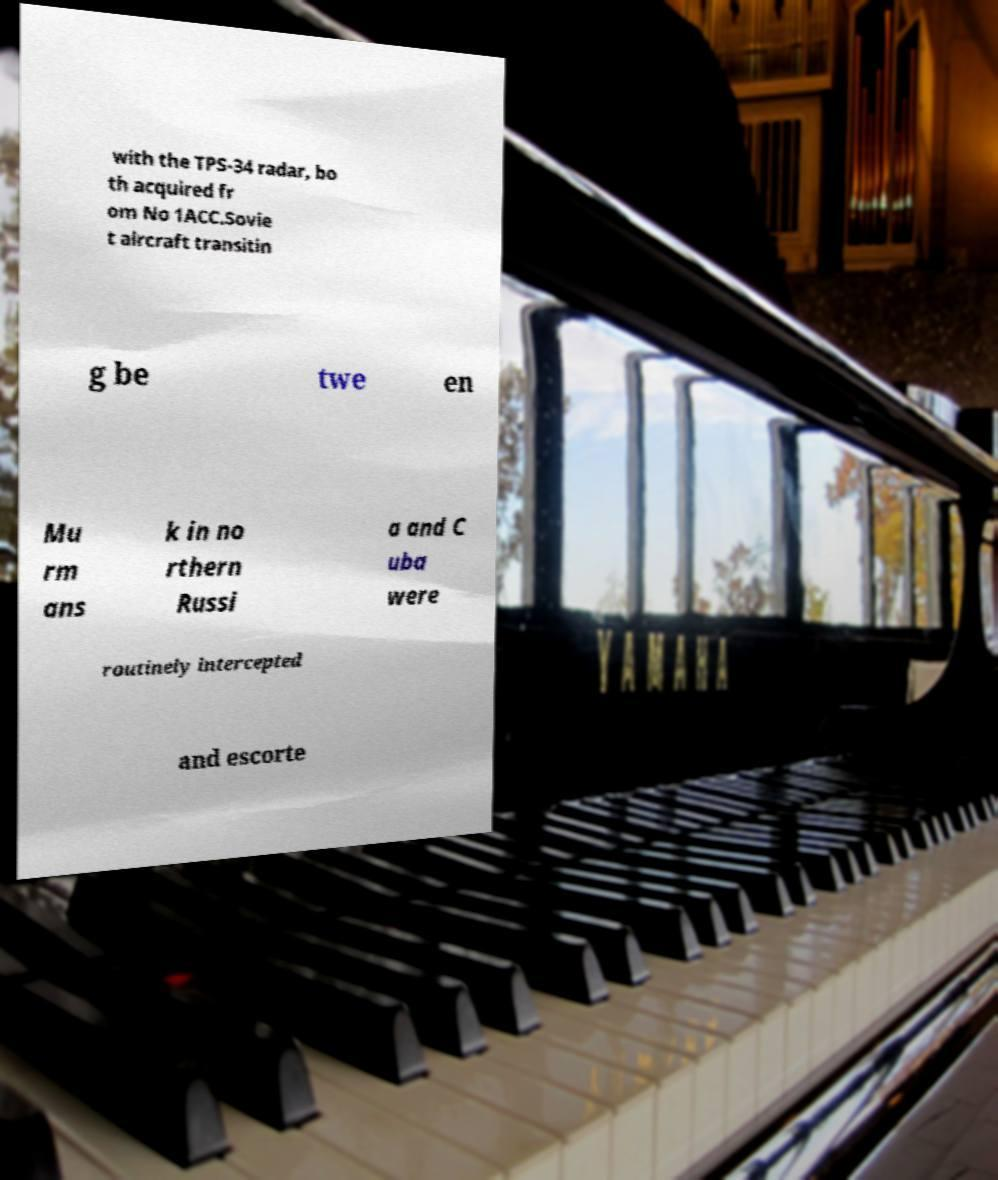Could you extract and type out the text from this image? with the TPS-34 radar, bo th acquired fr om No 1ACC.Sovie t aircraft transitin g be twe en Mu rm ans k in no rthern Russi a and C uba were routinely intercepted and escorte 